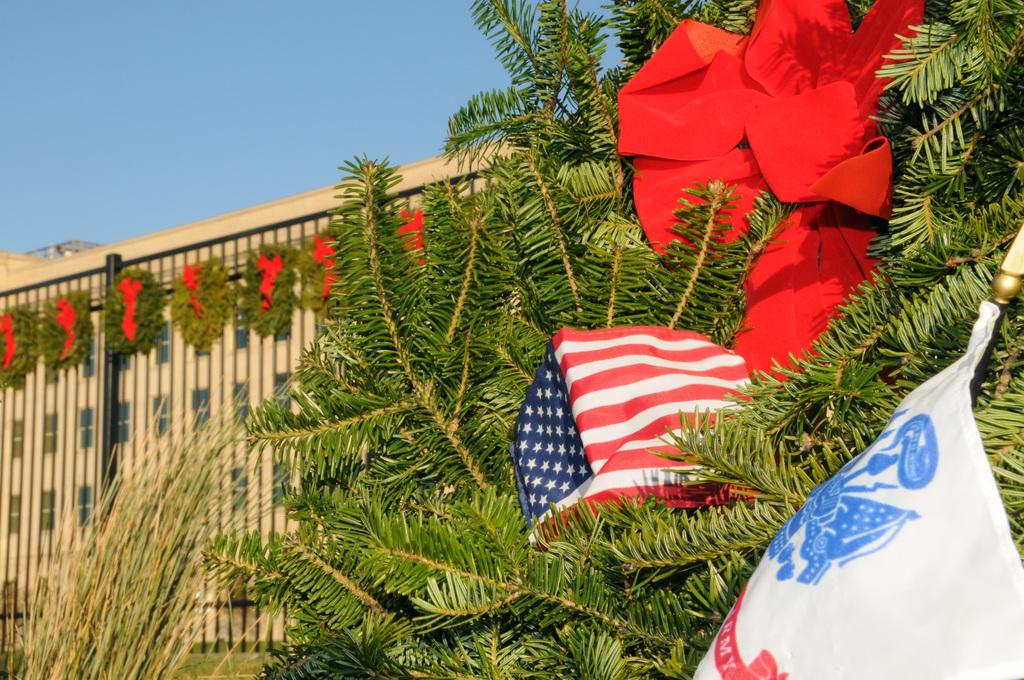What type of plant is in the image? The image contains a plant, but the specific type of plant is not mentioned. What is the flag cloth used for in the image? The flag cloth is present in the image, but its purpose or use is not specified. What is the ribbon used for in the image? The ribbon is used to decorate the building in the image. What structure is visible in the image? There is a building in the image. What part of the natural environment is visible in the image? The sky is partially visible in the image. What type of plastic is used to make the pipe in the image? There is no pipe present in the image, so it is not possible to determine the type of plastic used. How does the plant show respect to the flag cloth in the image? The plant does not show respect to the flag cloth in the image, as plants do not have the ability to express emotions or intentions. 